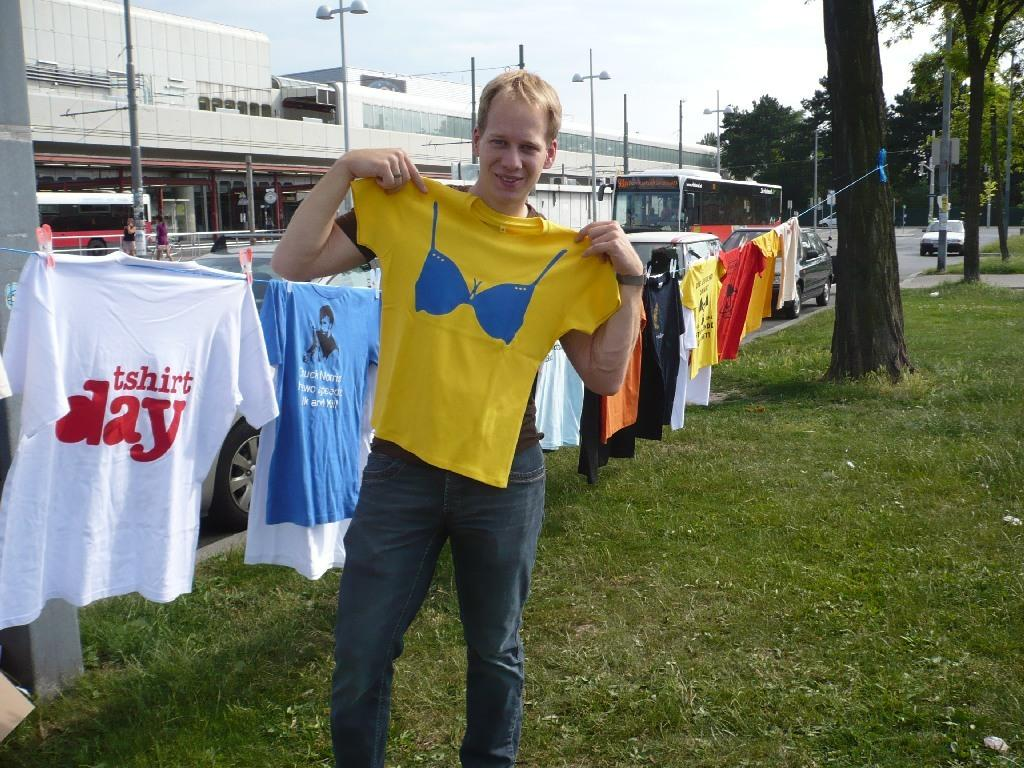<image>
Summarize the visual content of the image. The guy is displaying t shirts and it could be tshirt day. 